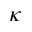Convert formula to latex. <formula><loc_0><loc_0><loc_500><loc_500>\kappa</formula> 